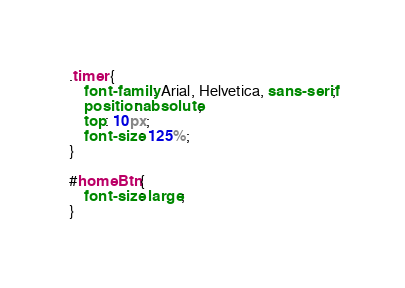Convert code to text. <code><loc_0><loc_0><loc_500><loc_500><_CSS_>
.timer {
    font-family: Arial, Helvetica, sans-serif;
    position: absolute;
    top: 10px;
    font-size: 125%;
}

#homeBtn {
    font-size: large;
}</code> 